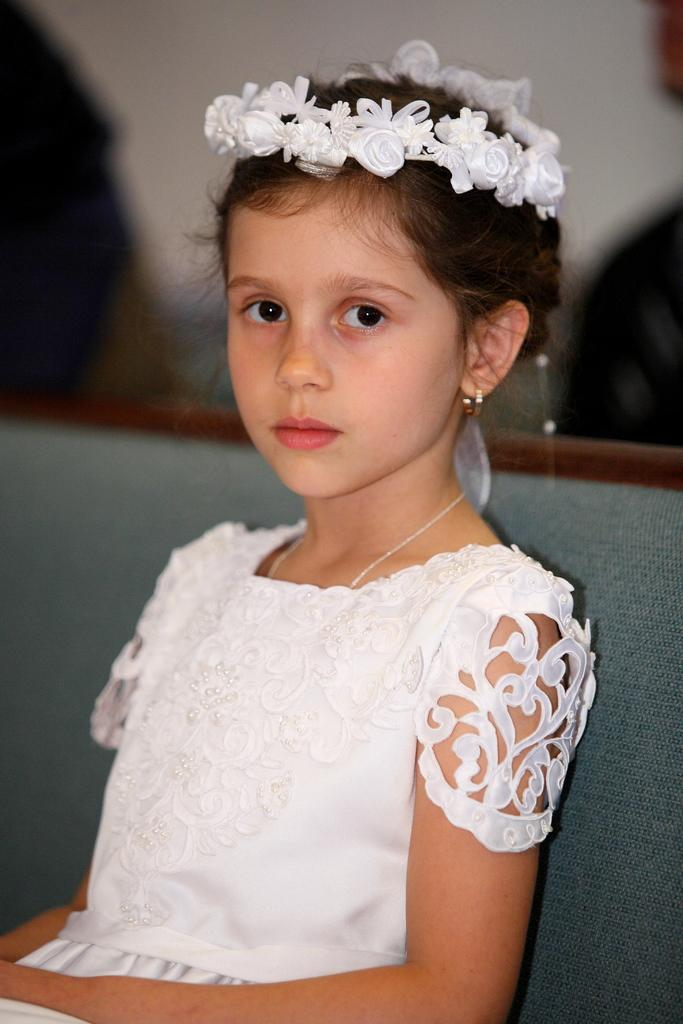Who is the main subject in the image? There is a girl in the image. What is the girl doing in the image? The girl is sitting on a chair. Can you describe the background of the image? The background of the image is blurry. What type of thumb is visible in the image? There is no thumb present in the image. Can you see any windows in the image? The provided facts do not mention any windows in the image. 